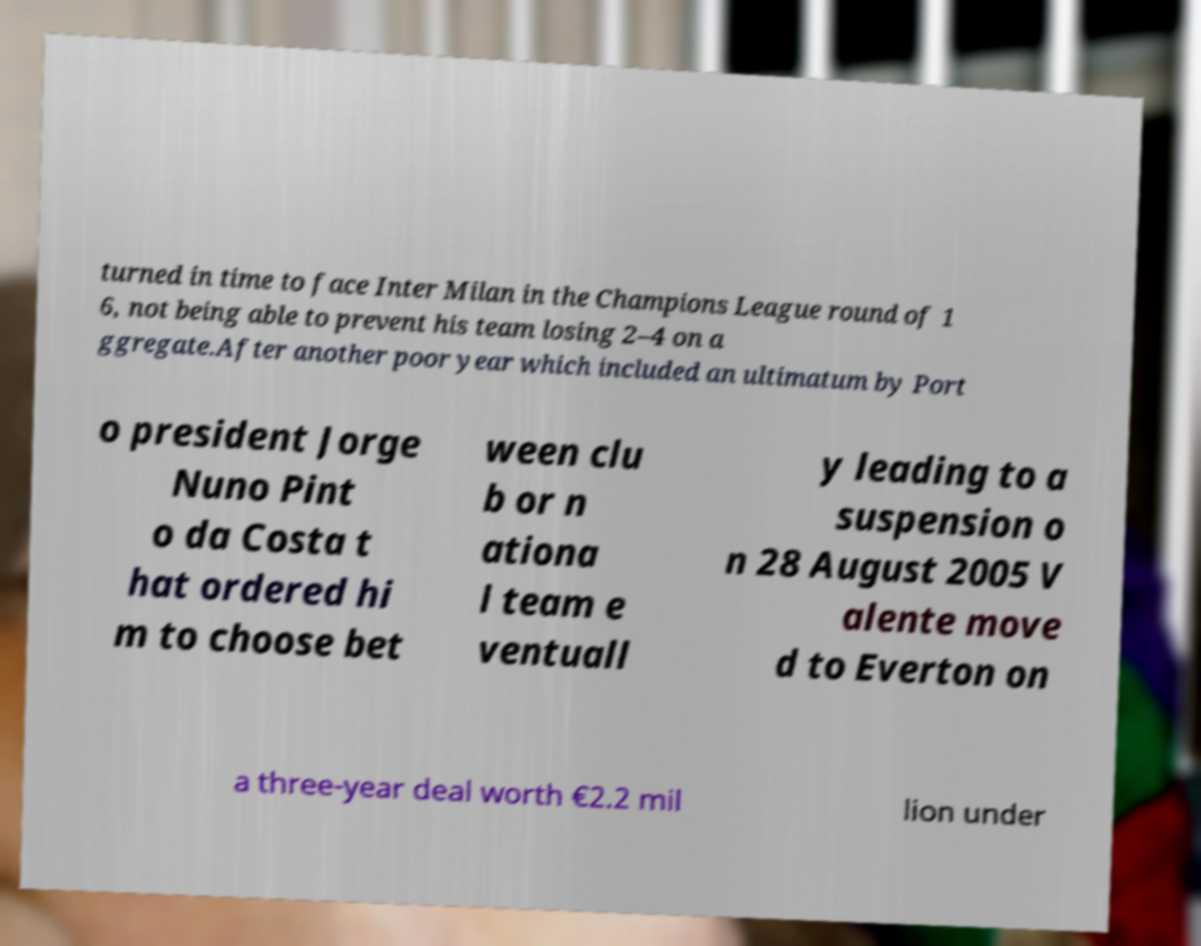Could you extract and type out the text from this image? turned in time to face Inter Milan in the Champions League round of 1 6, not being able to prevent his team losing 2–4 on a ggregate.After another poor year which included an ultimatum by Port o president Jorge Nuno Pint o da Costa t hat ordered hi m to choose bet ween clu b or n ationa l team e ventuall y leading to a suspension o n 28 August 2005 V alente move d to Everton on a three-year deal worth €2.2 mil lion under 